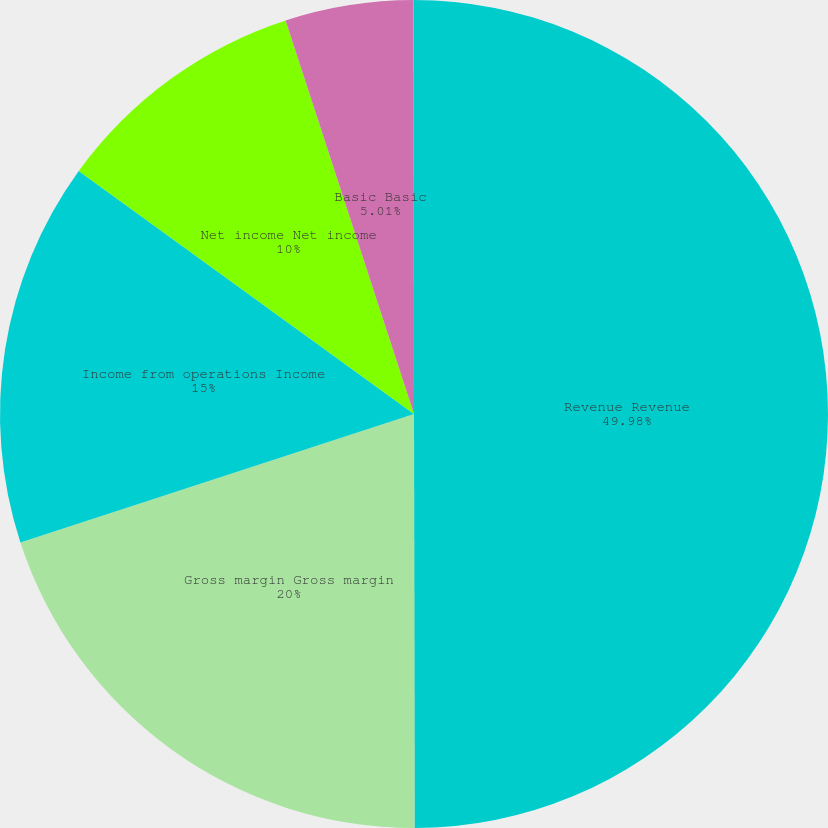<chart> <loc_0><loc_0><loc_500><loc_500><pie_chart><fcel>Revenue Revenue<fcel>Gross margin Gross margin<fcel>Income from operations Income<fcel>Net income Net income<fcel>Basic Basic<fcel>Diluted Diluted<nl><fcel>49.98%<fcel>20.0%<fcel>15.0%<fcel>10.0%<fcel>5.01%<fcel>0.01%<nl></chart> 